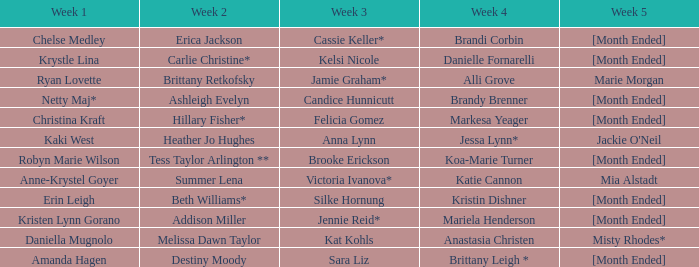What is the week 3 with addison miller in week 2? Jennie Reid*. 